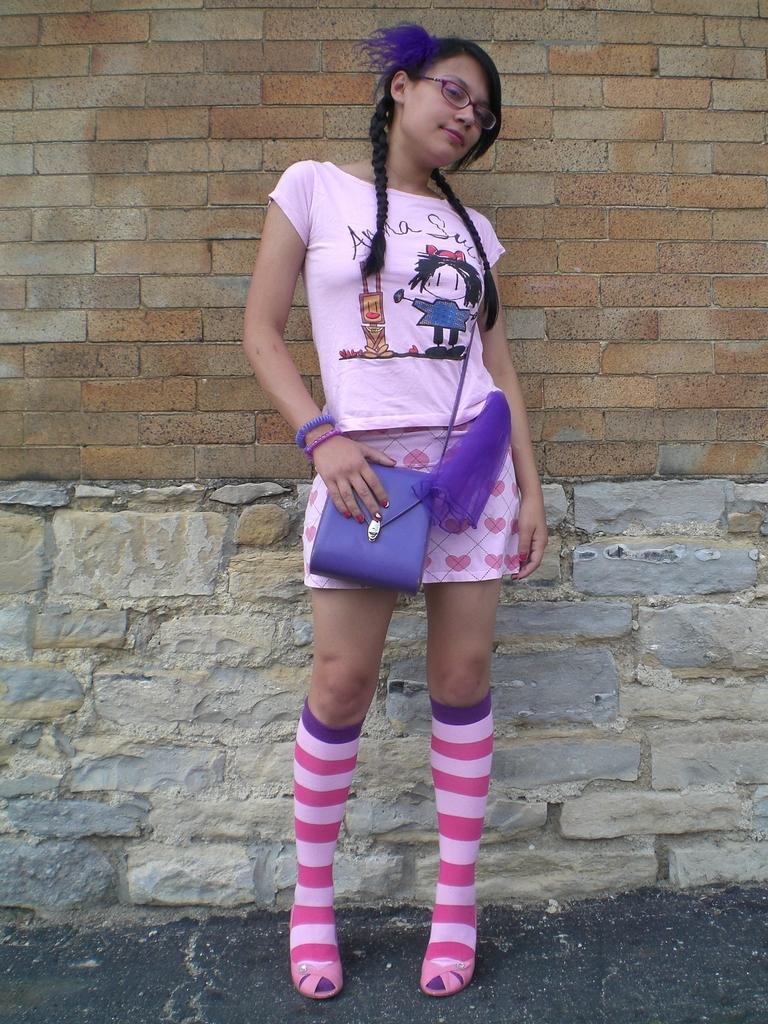What is the main subject of the image? There is a woman in the image. What is the woman wearing? The woman is wearing a pink t-shirt, a pink skirt, and pink socks. What can be seen in the background of the image? There is a wall with bricks in the background of the image. How does the woman use the grip on the cushion in the image? There is no cushion or grip present in the image. What note is the woman holding in the image? There is no note present in the image. 